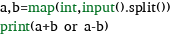<code> <loc_0><loc_0><loc_500><loc_500><_Python_>a,b=map(int,input().split())
print(a+b or a-b)
</code> 